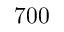Convert formula to latex. <formula><loc_0><loc_0><loc_500><loc_500>7 0 0</formula> 